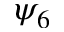<formula> <loc_0><loc_0><loc_500><loc_500>\psi _ { 6 }</formula> 